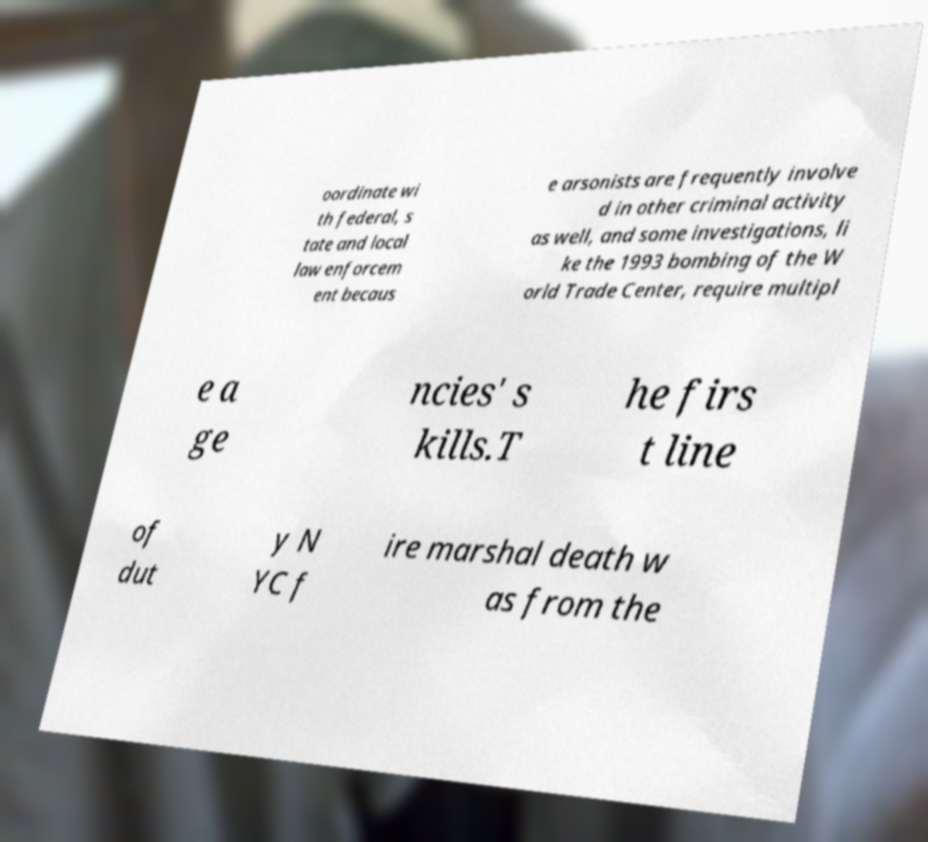For documentation purposes, I need the text within this image transcribed. Could you provide that? oordinate wi th federal, s tate and local law enforcem ent becaus e arsonists are frequently involve d in other criminal activity as well, and some investigations, li ke the 1993 bombing of the W orld Trade Center, require multipl e a ge ncies' s kills.T he firs t line of dut y N YC f ire marshal death w as from the 